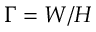<formula> <loc_0><loc_0><loc_500><loc_500>\Gamma = W / H</formula> 